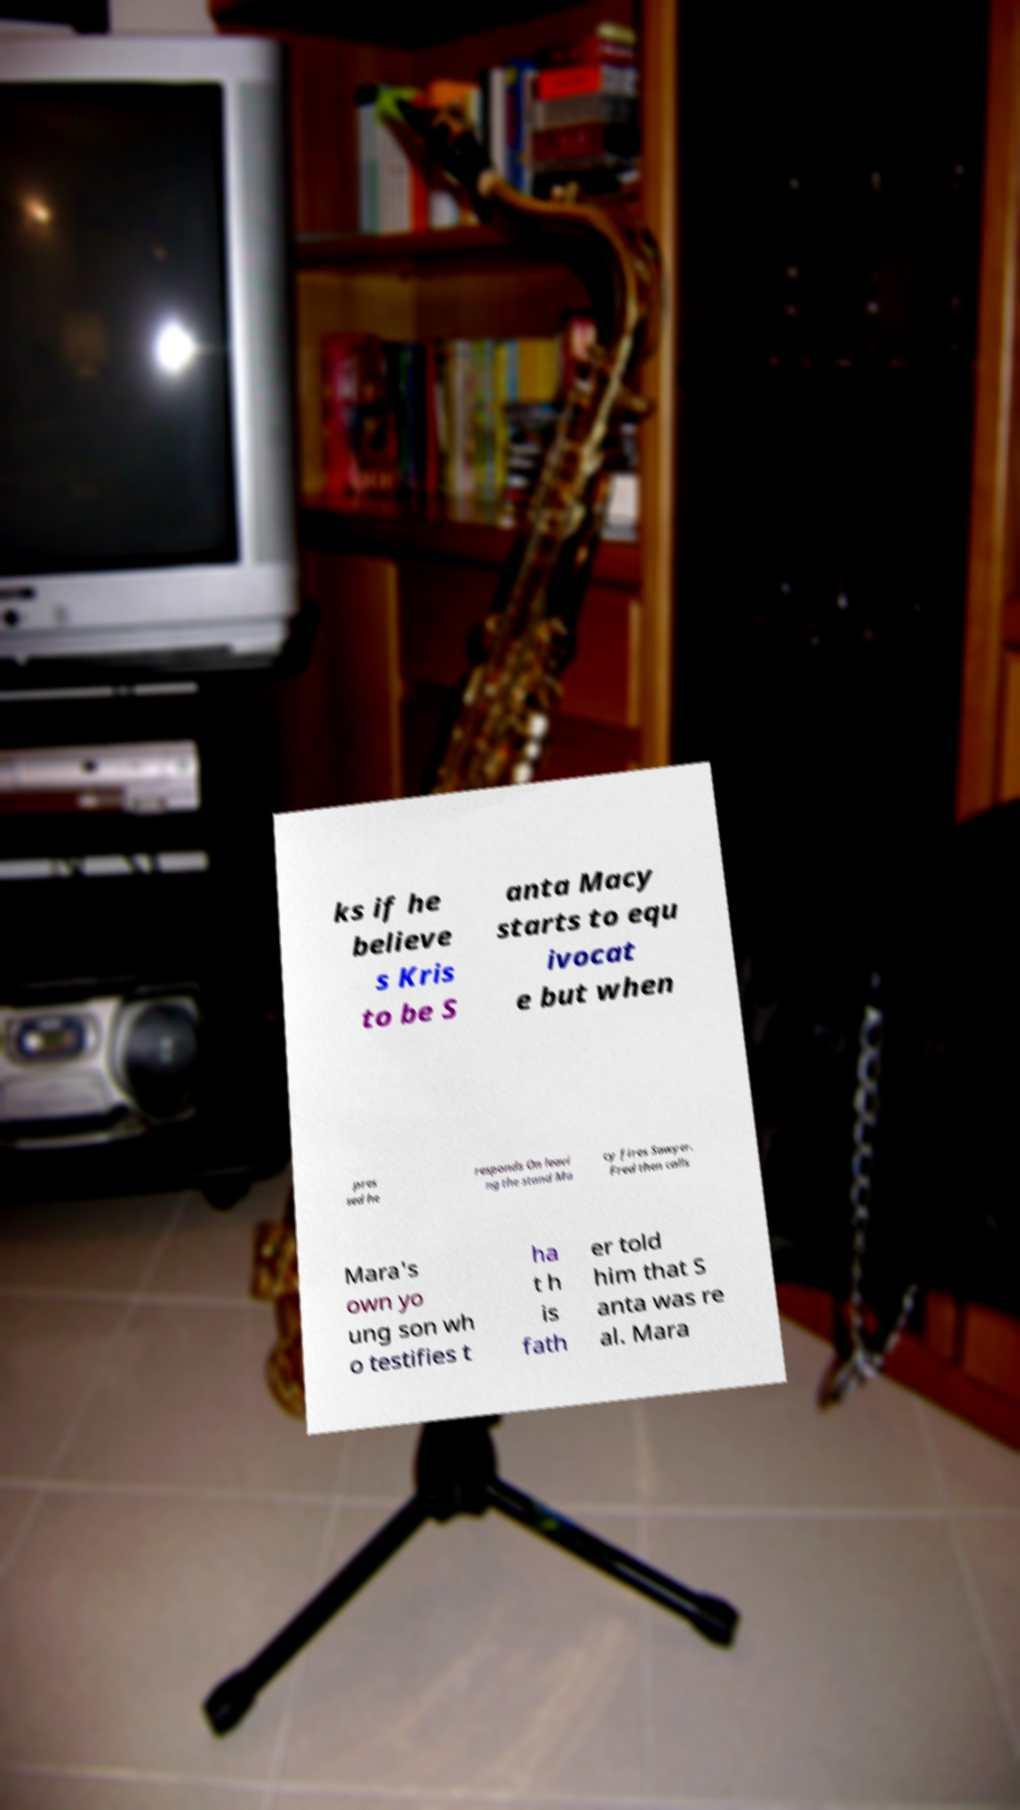Can you read and provide the text displayed in the image?This photo seems to have some interesting text. Can you extract and type it out for me? ks if he believe s Kris to be S anta Macy starts to equ ivocat e but when pres sed he responds On leavi ng the stand Ma cy fires Sawyer. Fred then calls Mara's own yo ung son wh o testifies t ha t h is fath er told him that S anta was re al. Mara 